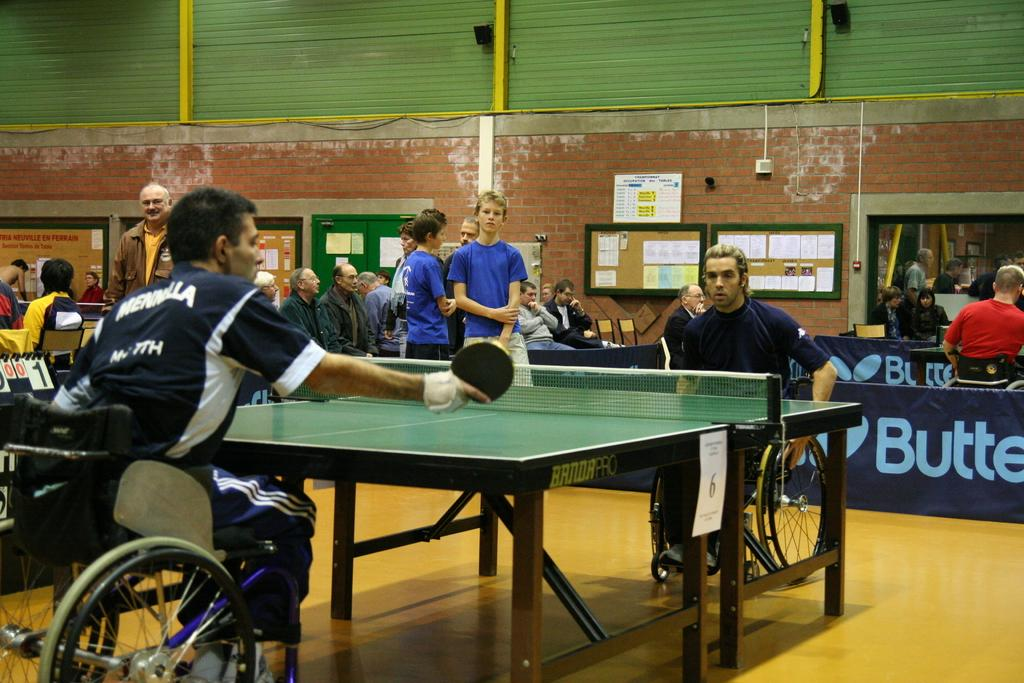What are the persons in the image doing while sitting on wheelchairs? They are playing table tennis. Can you describe the setting of the image? There are many people in the background of the image, and there are notice boards and a brick wall visible. What type of activity is being played in the image? The activity being played is table tennis. What type of rings can be seen on the table during the table tennis game? There are no rings visible on the table during the table tennis game in the image. Can you describe the feather used by the players in the game? There is no feather used in table tennis; it is a paddle and ball sport. 